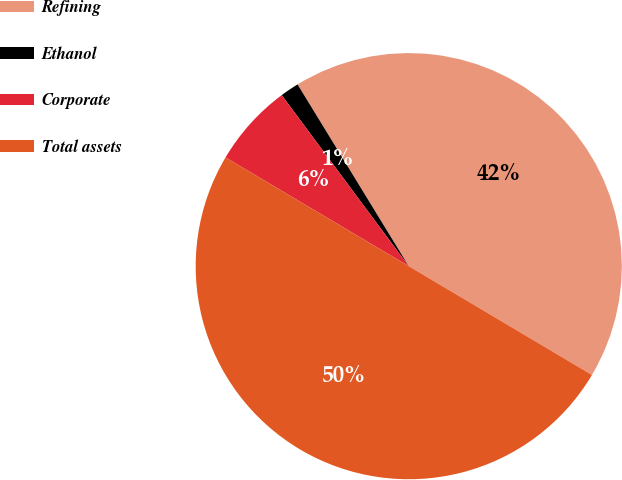<chart> <loc_0><loc_0><loc_500><loc_500><pie_chart><fcel>Refining<fcel>Ethanol<fcel>Corporate<fcel>Total assets<nl><fcel>42.27%<fcel>1.43%<fcel>6.31%<fcel>50.0%<nl></chart> 